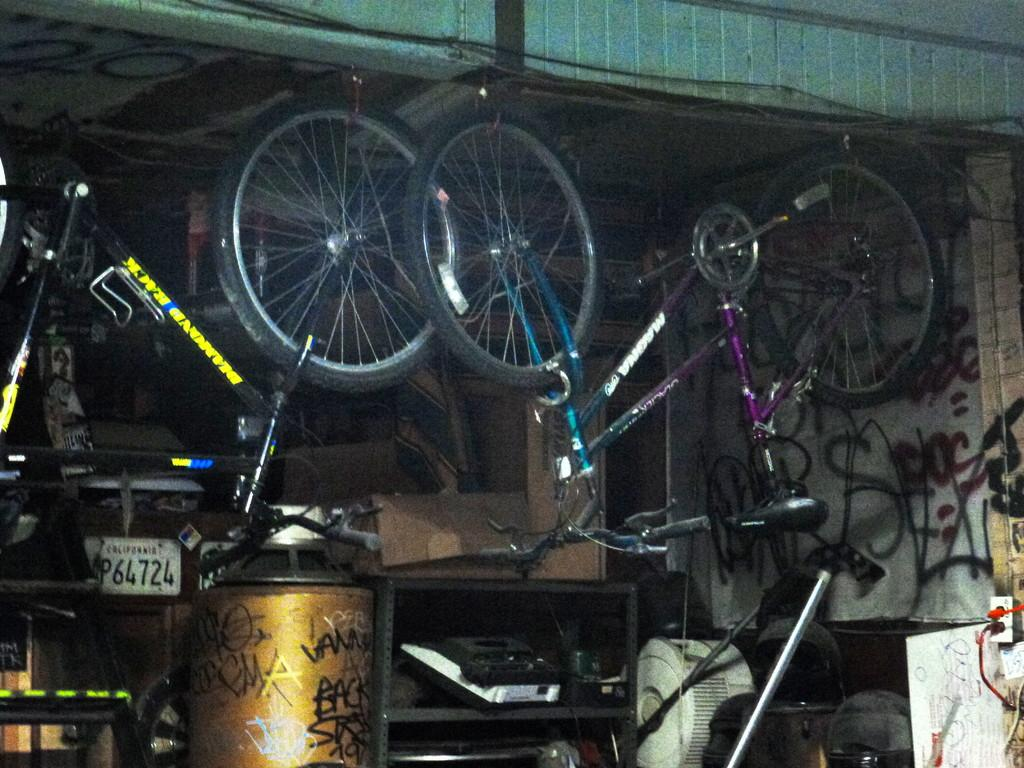What type of vehicles are in the image? There are bicycles in the image. What is on the floor in the image? There are objects on the floor in the image. What is the color and purpose of the rack in the image? There is a black color rack in the image, which may be used for storing or organizing items. What type of stamp can be seen on the bicycle seat in the image? There is no stamp visible on the bicycle seat or any other part of the bicycles in the image. 